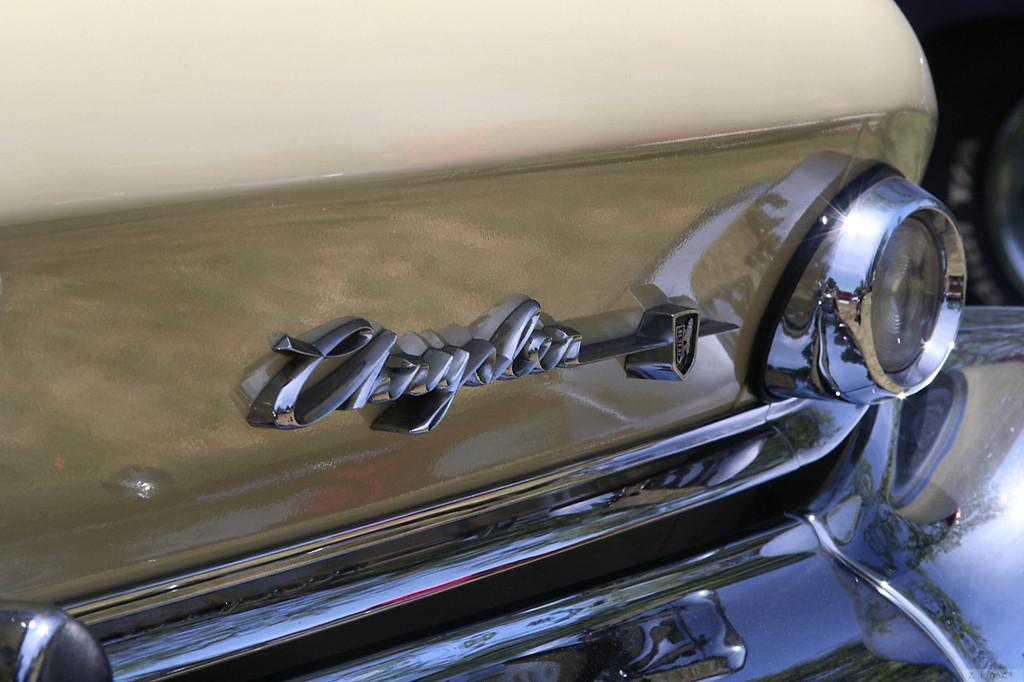What is the main subject in the foreground of the image? There is a truncated part of a car in the foreground of the image. Can you describe any specific features of the car? Yes, there is a logo on the car. What type of ground can be seen beneath the car in the image? There is no ground visible beneath the car in the image, as only a truncated part of the car is shown. Can you describe the reaction of the cat in the image? There is no cat present in the image. 